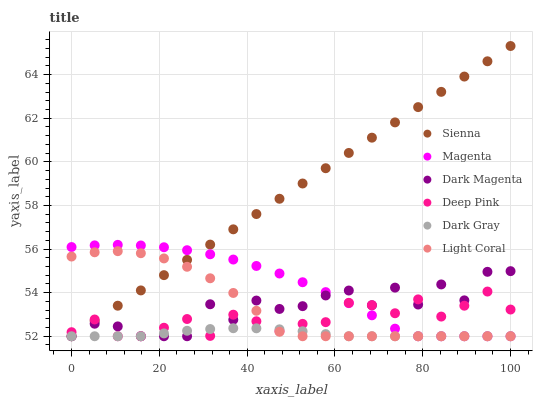Does Dark Gray have the minimum area under the curve?
Answer yes or no. Yes. Does Sienna have the maximum area under the curve?
Answer yes or no. Yes. Does Deep Pink have the minimum area under the curve?
Answer yes or no. No. Does Deep Pink have the maximum area under the curve?
Answer yes or no. No. Is Sienna the smoothest?
Answer yes or no. Yes. Is Dark Magenta the roughest?
Answer yes or no. Yes. Is Deep Pink the smoothest?
Answer yes or no. No. Is Deep Pink the roughest?
Answer yes or no. No. Does Dark Gray have the lowest value?
Answer yes or no. Yes. Does Sienna have the highest value?
Answer yes or no. Yes. Does Deep Pink have the highest value?
Answer yes or no. No. Does Magenta intersect Dark Magenta?
Answer yes or no. Yes. Is Magenta less than Dark Magenta?
Answer yes or no. No. Is Magenta greater than Dark Magenta?
Answer yes or no. No. 